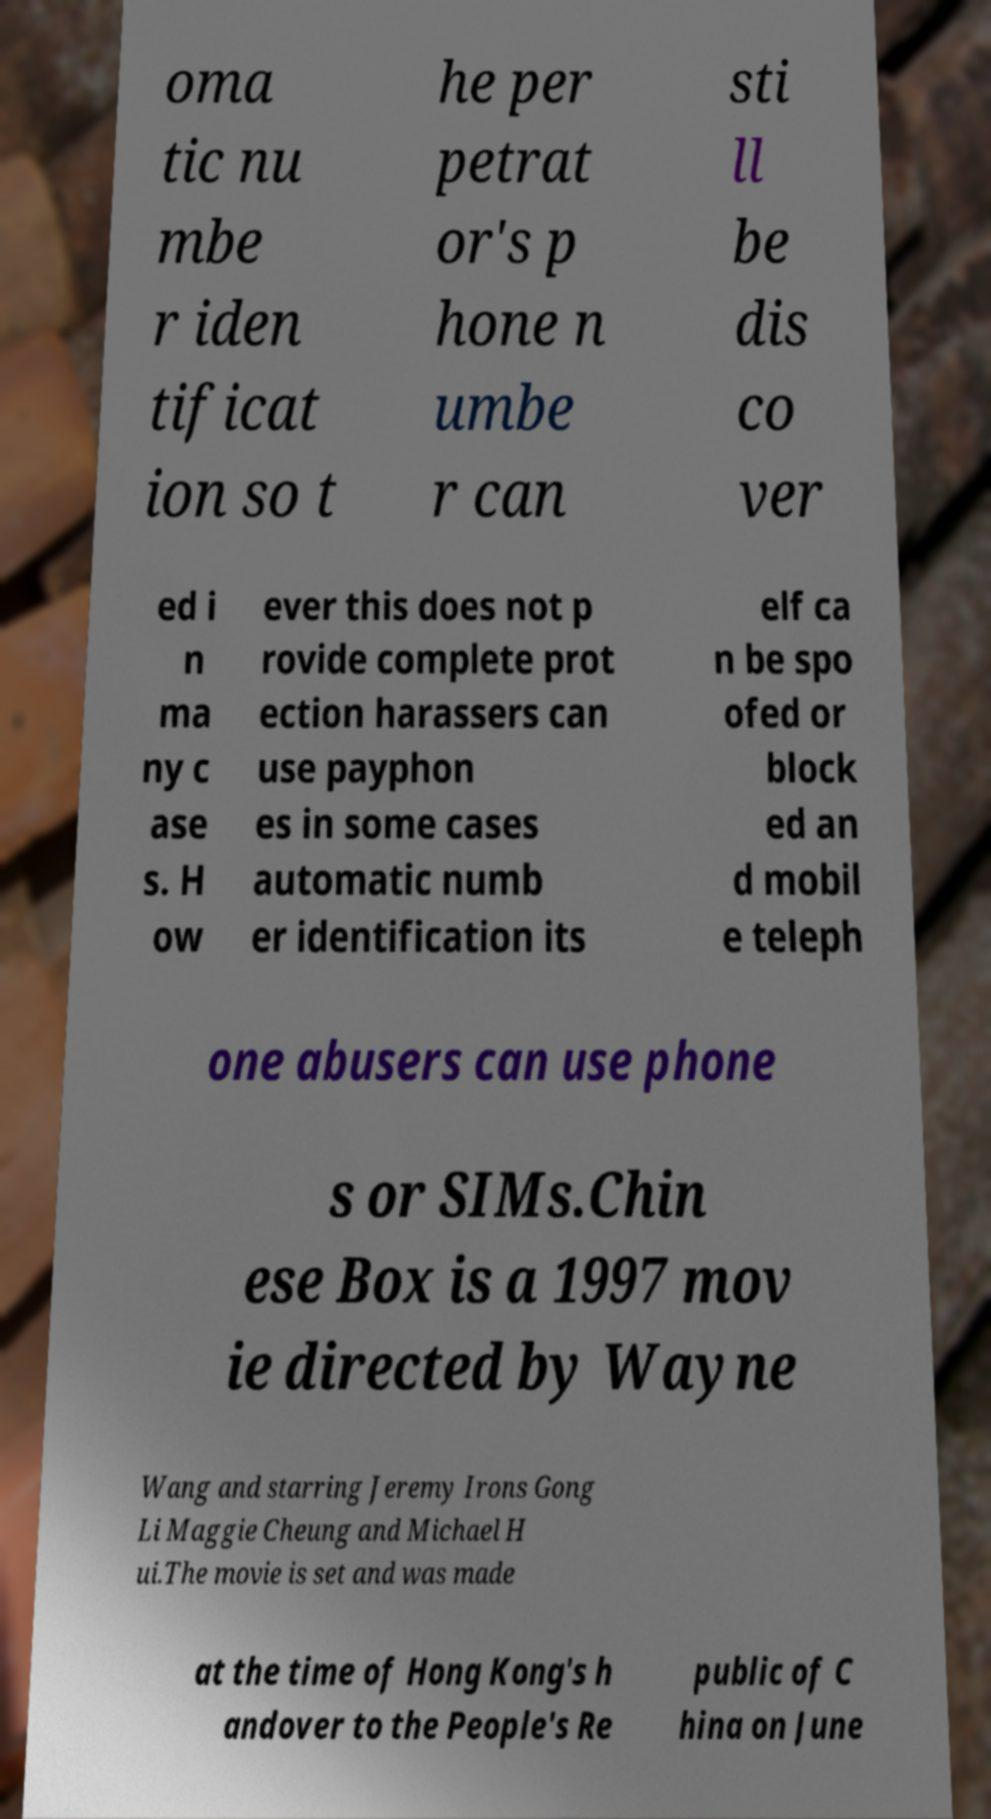Can you accurately transcribe the text from the provided image for me? oma tic nu mbe r iden tificat ion so t he per petrat or's p hone n umbe r can sti ll be dis co ver ed i n ma ny c ase s. H ow ever this does not p rovide complete prot ection harassers can use payphon es in some cases automatic numb er identification its elf ca n be spo ofed or block ed an d mobil e teleph one abusers can use phone s or SIMs.Chin ese Box is a 1997 mov ie directed by Wayne Wang and starring Jeremy Irons Gong Li Maggie Cheung and Michael H ui.The movie is set and was made at the time of Hong Kong's h andover to the People's Re public of C hina on June 